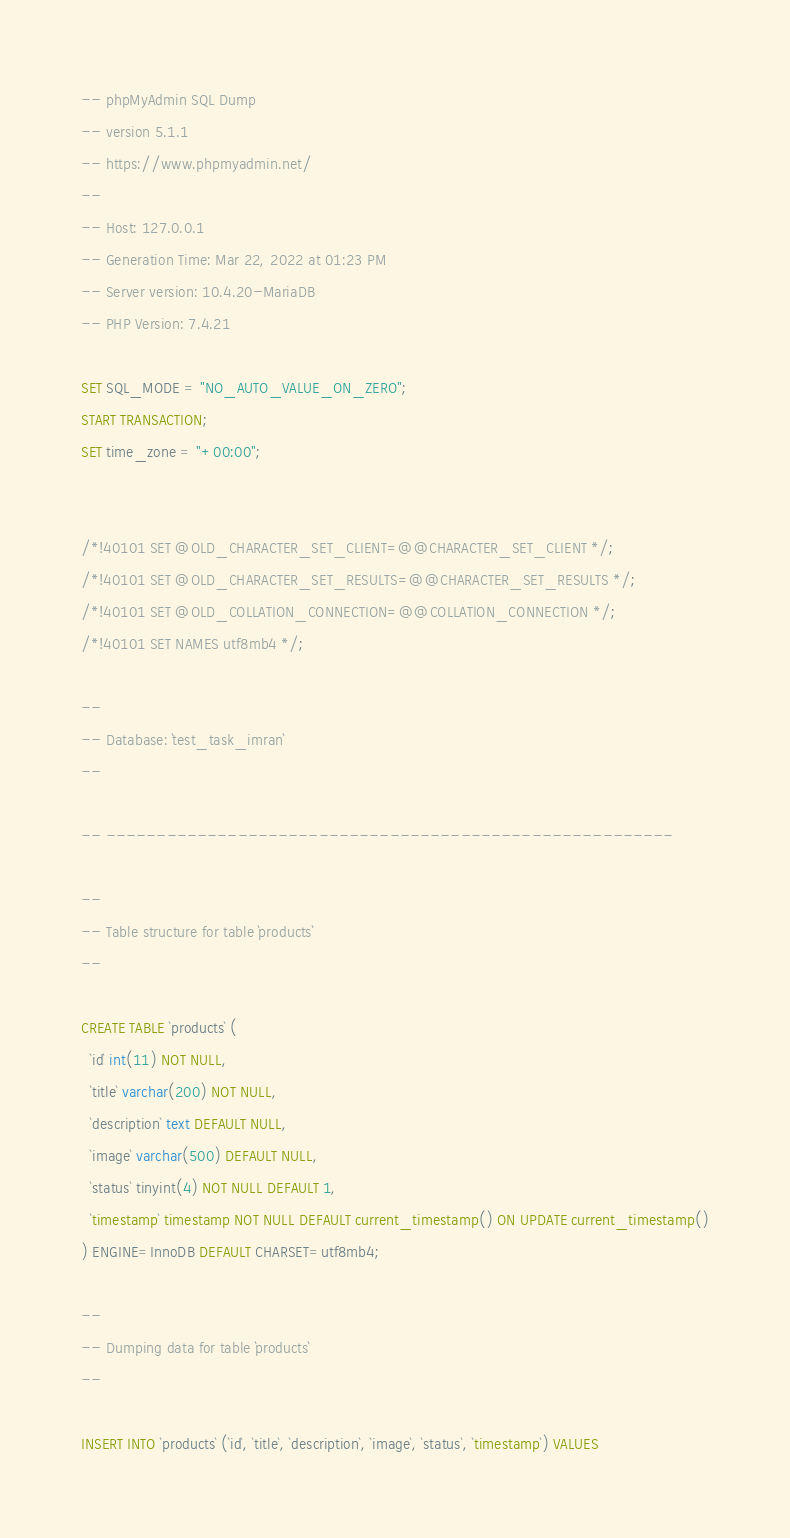Convert code to text. <code><loc_0><loc_0><loc_500><loc_500><_SQL_>-- phpMyAdmin SQL Dump
-- version 5.1.1
-- https://www.phpmyadmin.net/
--
-- Host: 127.0.0.1
-- Generation Time: Mar 22, 2022 at 01:23 PM
-- Server version: 10.4.20-MariaDB
-- PHP Version: 7.4.21

SET SQL_MODE = "NO_AUTO_VALUE_ON_ZERO";
START TRANSACTION;
SET time_zone = "+00:00";


/*!40101 SET @OLD_CHARACTER_SET_CLIENT=@@CHARACTER_SET_CLIENT */;
/*!40101 SET @OLD_CHARACTER_SET_RESULTS=@@CHARACTER_SET_RESULTS */;
/*!40101 SET @OLD_COLLATION_CONNECTION=@@COLLATION_CONNECTION */;
/*!40101 SET NAMES utf8mb4 */;

--
-- Database: `test_task_imran`
--

-- --------------------------------------------------------

--
-- Table structure for table `products`
--

CREATE TABLE `products` (
  `id` int(11) NOT NULL,
  `title` varchar(200) NOT NULL,
  `description` text DEFAULT NULL,
  `image` varchar(500) DEFAULT NULL,
  `status` tinyint(4) NOT NULL DEFAULT 1,
  `timestamp` timestamp NOT NULL DEFAULT current_timestamp() ON UPDATE current_timestamp()
) ENGINE=InnoDB DEFAULT CHARSET=utf8mb4;

--
-- Dumping data for table `products`
--

INSERT INTO `products` (`id`, `title`, `description`, `image`, `status`, `timestamp`) VALUES</code> 